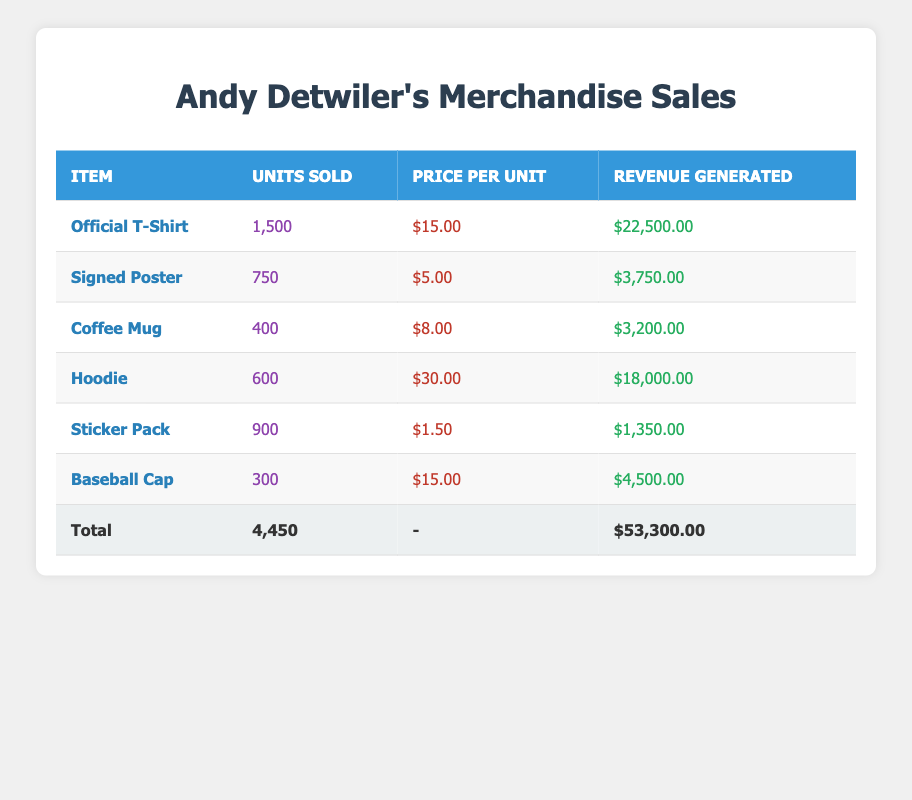What item generated the most revenue? Looking through the "revenue generated" column, the item "Official T-Shirt" has the highest value at $22,500.
Answer: Official T-Shirt How many units of the Coffee Mug were sold? Directly referring to the "units sold" column for the Coffee Mug, it shows that 400 units were sold.
Answer: 400 What is the total revenue generated from all the merchandise sales? To find the total revenue, we sum up all the values in the "revenue generated" column: $22,500 + $3,750 + $3,200 + $18,000 + $1,350 + $4,500 = $53,300.
Answer: $53,300 Did more units of Hoodies or Baseball Caps get sold? Comparing the "units sold" values, Hoodies had 600 units sold, while Baseball Caps had 300 units sold, so Hoodies had more sales.
Answer: Yes What is the average price per unit of all merchandise items? To find the average price per unit, we sum the prices and divide by the number of items: ($15 + $5 + $8 + $30 + $1.5 + $15) / 6 = $9.25.
Answer: $9.25 How much revenue did the Sticker Pack generate compared to the Signed Poster? The revenue for Sticker Packs is $1,350 and for Signed Posters is $3,750. Thus, Signed Posters generated more than Sticker Packs.
Answer: No Which merchandise item contributed to the highest percentage of total sales revenue? To find this, we calculate the percentage contribution of each item's revenue. The Official T-Shirt's revenue ($22,500) over total revenue ($53,300) is approximately 42.16%, making it the highest contributor.
Answer: Official T-Shirt What is the difference in revenue generated between Hoodies and Coffee Mugs? The revenue for Hoodies is $18,000 and for Coffee Mugs is $3,200. The difference is calculated as $18,000 - $3,200 = $14,800.
Answer: $14,800 Is the revenue generated from the Sticker Pack less than that of the Coffee Mug? The revenue for Sticker Packs is $1,350 and for Coffee Mugs is $3,200. Comparing them shows that Sticker Packs generated less revenue than Coffee Mugs.
Answer: Yes 